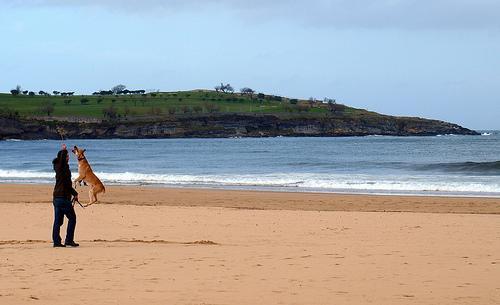How many dogs are visible?
Give a very brief answer. 1. 